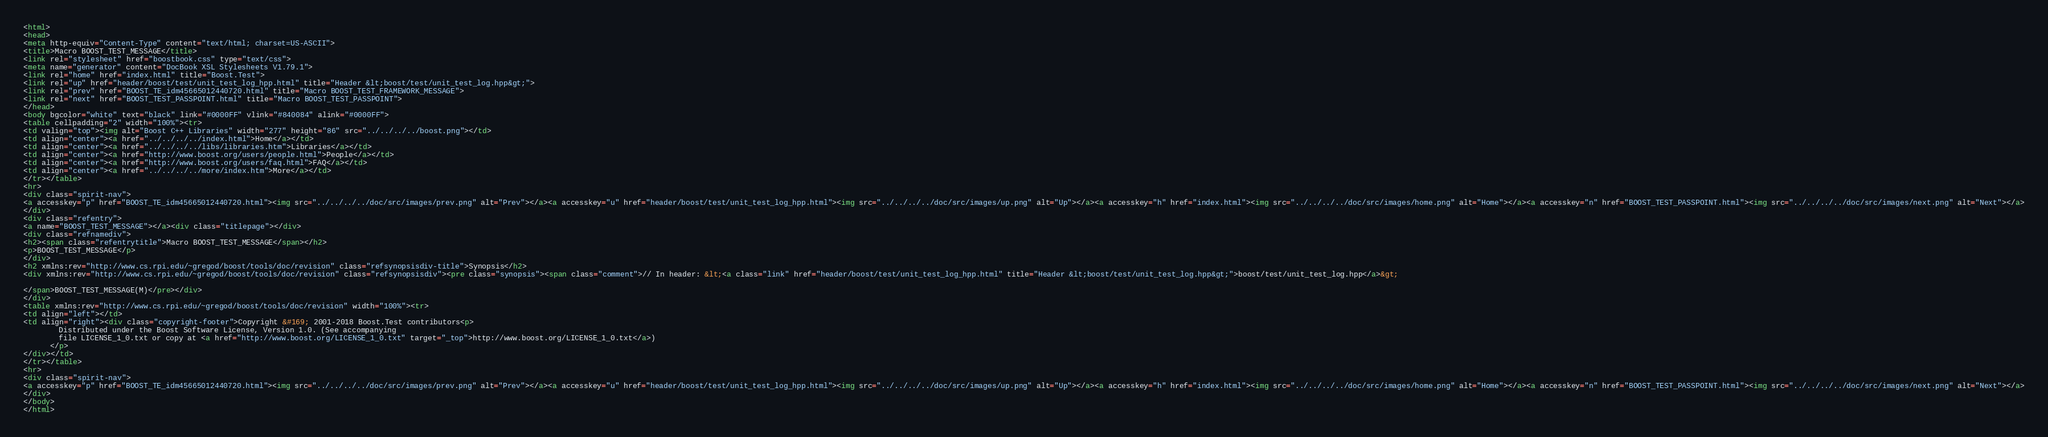<code> <loc_0><loc_0><loc_500><loc_500><_HTML_><html>
<head>
<meta http-equiv="Content-Type" content="text/html; charset=US-ASCII">
<title>Macro BOOST_TEST_MESSAGE</title>
<link rel="stylesheet" href="boostbook.css" type="text/css">
<meta name="generator" content="DocBook XSL Stylesheets V1.79.1">
<link rel="home" href="index.html" title="Boost.Test">
<link rel="up" href="header/boost/test/unit_test_log_hpp.html" title="Header &lt;boost/test/unit_test_log.hpp&gt;">
<link rel="prev" href="BOOST_TE_idm45665012440720.html" title="Macro BOOST_TEST_FRAMEWORK_MESSAGE">
<link rel="next" href="BOOST_TEST_PASSPOINT.html" title="Macro BOOST_TEST_PASSPOINT">
</head>
<body bgcolor="white" text="black" link="#0000FF" vlink="#840084" alink="#0000FF">
<table cellpadding="2" width="100%"><tr>
<td valign="top"><img alt="Boost C++ Libraries" width="277" height="86" src="../../../../boost.png"></td>
<td align="center"><a href="../../../../index.html">Home</a></td>
<td align="center"><a href="../../../../libs/libraries.htm">Libraries</a></td>
<td align="center"><a href="http://www.boost.org/users/people.html">People</a></td>
<td align="center"><a href="http://www.boost.org/users/faq.html">FAQ</a></td>
<td align="center"><a href="../../../../more/index.htm">More</a></td>
</tr></table>
<hr>
<div class="spirit-nav">
<a accesskey="p" href="BOOST_TE_idm45665012440720.html"><img src="../../../../doc/src/images/prev.png" alt="Prev"></a><a accesskey="u" href="header/boost/test/unit_test_log_hpp.html"><img src="../../../../doc/src/images/up.png" alt="Up"></a><a accesskey="h" href="index.html"><img src="../../../../doc/src/images/home.png" alt="Home"></a><a accesskey="n" href="BOOST_TEST_PASSPOINT.html"><img src="../../../../doc/src/images/next.png" alt="Next"></a>
</div>
<div class="refentry">
<a name="BOOST_TEST_MESSAGE"></a><div class="titlepage"></div>
<div class="refnamediv">
<h2><span class="refentrytitle">Macro BOOST_TEST_MESSAGE</span></h2>
<p>BOOST_TEST_MESSAGE</p>
</div>
<h2 xmlns:rev="http://www.cs.rpi.edu/~gregod/boost/tools/doc/revision" class="refsynopsisdiv-title">Synopsis</h2>
<div xmlns:rev="http://www.cs.rpi.edu/~gregod/boost/tools/doc/revision" class="refsynopsisdiv"><pre class="synopsis"><span class="comment">// In header: &lt;<a class="link" href="header/boost/test/unit_test_log_hpp.html" title="Header &lt;boost/test/unit_test_log.hpp&gt;">boost/test/unit_test_log.hpp</a>&gt;

</span>BOOST_TEST_MESSAGE(M)</pre></div>
</div>
<table xmlns:rev="http://www.cs.rpi.edu/~gregod/boost/tools/doc/revision" width="100%"><tr>
<td align="left"></td>
<td align="right"><div class="copyright-footer">Copyright &#169; 2001-2018 Boost.Test contributors<p>
        Distributed under the Boost Software License, Version 1.0. (See accompanying
        file LICENSE_1_0.txt or copy at <a href="http://www.boost.org/LICENSE_1_0.txt" target="_top">http://www.boost.org/LICENSE_1_0.txt</a>)
      </p>
</div></td>
</tr></table>
<hr>
<div class="spirit-nav">
<a accesskey="p" href="BOOST_TE_idm45665012440720.html"><img src="../../../../doc/src/images/prev.png" alt="Prev"></a><a accesskey="u" href="header/boost/test/unit_test_log_hpp.html"><img src="../../../../doc/src/images/up.png" alt="Up"></a><a accesskey="h" href="index.html"><img src="../../../../doc/src/images/home.png" alt="Home"></a><a accesskey="n" href="BOOST_TEST_PASSPOINT.html"><img src="../../../../doc/src/images/next.png" alt="Next"></a>
</div>
</body>
</html>
</code> 